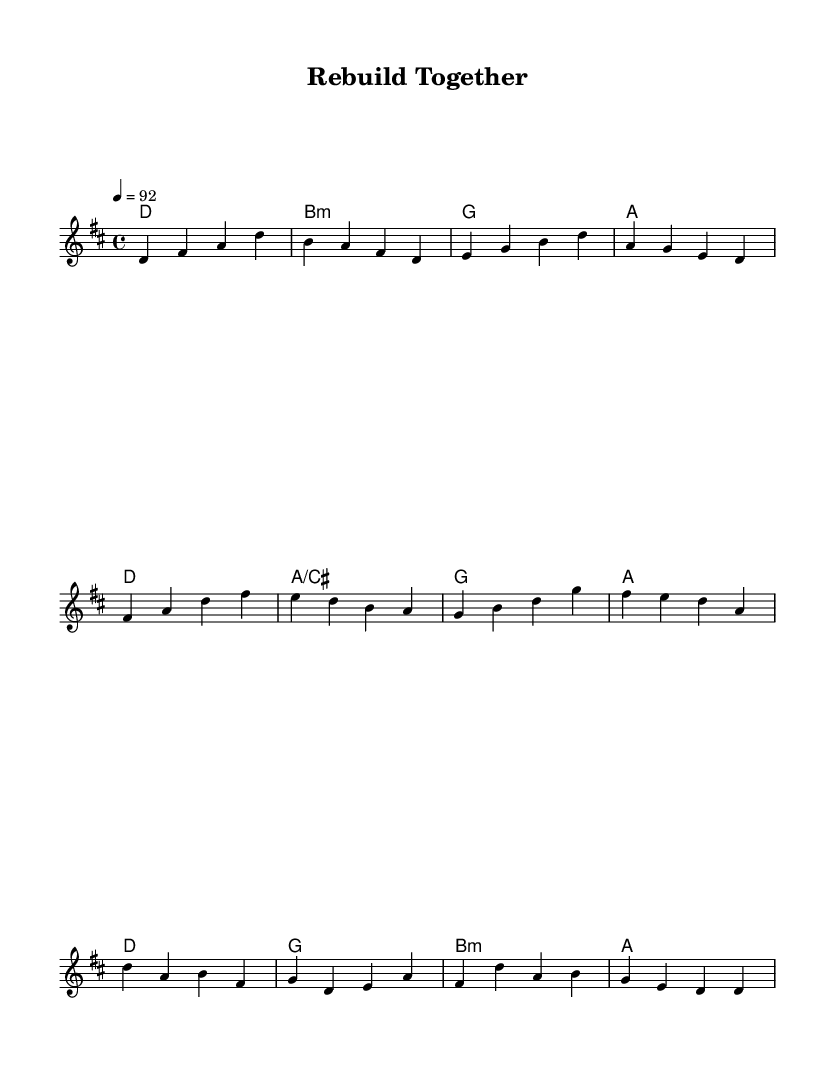What is the key signature of this music? The key signature is D major, which has two sharps (F# and C#). This can be identified at the beginning of the staff where the sharps are indicated.
Answer: D major What is the time signature of this piece? The time signature is 4/4, which indicates that there are four beats in each measure and a quarter note gets one beat. This is often visually shown at the beginning of the sheet music.
Answer: 4/4 What is the tempo marking for this song? The tempo marking is 92 beats per minute, which is indicated in the score as "4 = 92." This means the quarter note should be played at this speed.
Answer: 92 How many sections does this piece have? The piece has three sections indicated: Verse, Pre-Chorus, and Chorus, which can be discerned from the structure of the melody.
Answer: Three What chord follows the 'E' note in the pre-chorus? The chord following the 'E' note in the pre-chorus is a D major chord, which can be found listed above the melody at that point in the score.
Answer: D Which section starts with an F# note? The section that starts with an F# note is the Pre-Chorus, identifiable by the musical notations and the respective melody that begins with F#.
Answer: Pre-Chorus What is the relationship between the melody and harmonies in the verse section? The melody in the verse section interacts with the harmonies by matching the D major chord while providing a vocal line that complements the chord progression outlined above it.
Answer: D major chord 